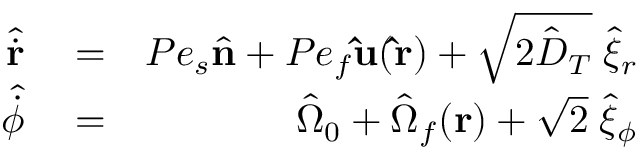<formula> <loc_0><loc_0><loc_500><loc_500>\begin{array} { r l r } { \hat { \dot { \mathbf r } } } & = } & { P e _ { s } \hat { \mathbf n } + P e _ { f } \hat { u } ( \hat { r } ) + \sqrt { 2 \hat { D } _ { T } } \, \hat { \xi } _ { r } } \\ { \hat { \dot { \phi } } } & = } & { \hat { \Omega } _ { 0 } + \hat { \Omega } _ { f } ( \mathbf r ) + \sqrt { 2 } \, \hat { \xi } _ { \phi } } \end{array}</formula> 